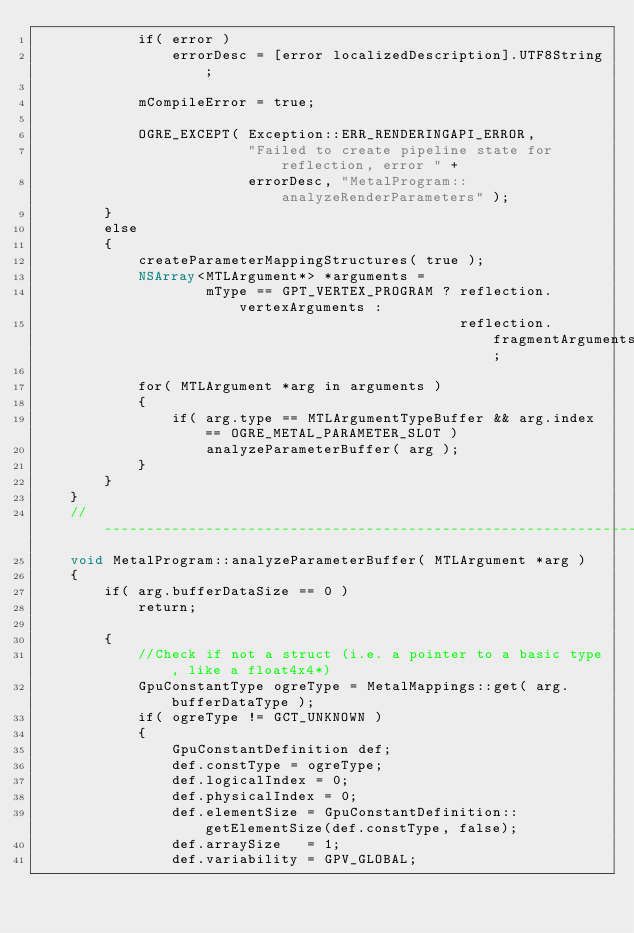Convert code to text. <code><loc_0><loc_0><loc_500><loc_500><_ObjectiveC_>            if( error )
                errorDesc = [error localizedDescription].UTF8String;

            mCompileError = true;

            OGRE_EXCEPT( Exception::ERR_RENDERINGAPI_ERROR,
                         "Failed to create pipeline state for reflection, error " +
                         errorDesc, "MetalProgram::analyzeRenderParameters" );
        }
        else
        {
            createParameterMappingStructures( true );
            NSArray<MTLArgument*> *arguments =
                    mType == GPT_VERTEX_PROGRAM ? reflection.vertexArguments :
                                                  reflection.fragmentArguments;

            for( MTLArgument *arg in arguments )
            {
                if( arg.type == MTLArgumentTypeBuffer && arg.index == OGRE_METAL_PARAMETER_SLOT )
                    analyzeParameterBuffer( arg );
            }
        }
    }
    //-----------------------------------------------------------------------
    void MetalProgram::analyzeParameterBuffer( MTLArgument *arg )
    {
        if( arg.bufferDataSize == 0 )
            return;

        {
            //Check if not a struct (i.e. a pointer to a basic type, like a float4x4*)
            GpuConstantType ogreType = MetalMappings::get( arg.bufferDataType );
            if( ogreType != GCT_UNKNOWN )
            {
                GpuConstantDefinition def;
                def.constType = ogreType;
                def.logicalIndex = 0;
                def.physicalIndex = 0;
                def.elementSize = GpuConstantDefinition::getElementSize(def.constType, false);
                def.arraySize   = 1;
                def.variability = GPV_GLOBAL;
</code> 